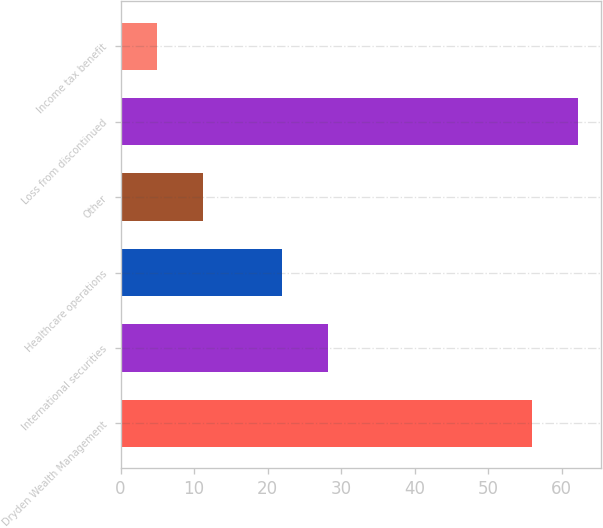Convert chart to OTSL. <chart><loc_0><loc_0><loc_500><loc_500><bar_chart><fcel>Dryden Wealth Management<fcel>International securities<fcel>Healthcare operations<fcel>Other<fcel>Loss from discontinued<fcel>Income tax benefit<nl><fcel>56<fcel>28.2<fcel>22<fcel>11.2<fcel>62.2<fcel>5<nl></chart> 